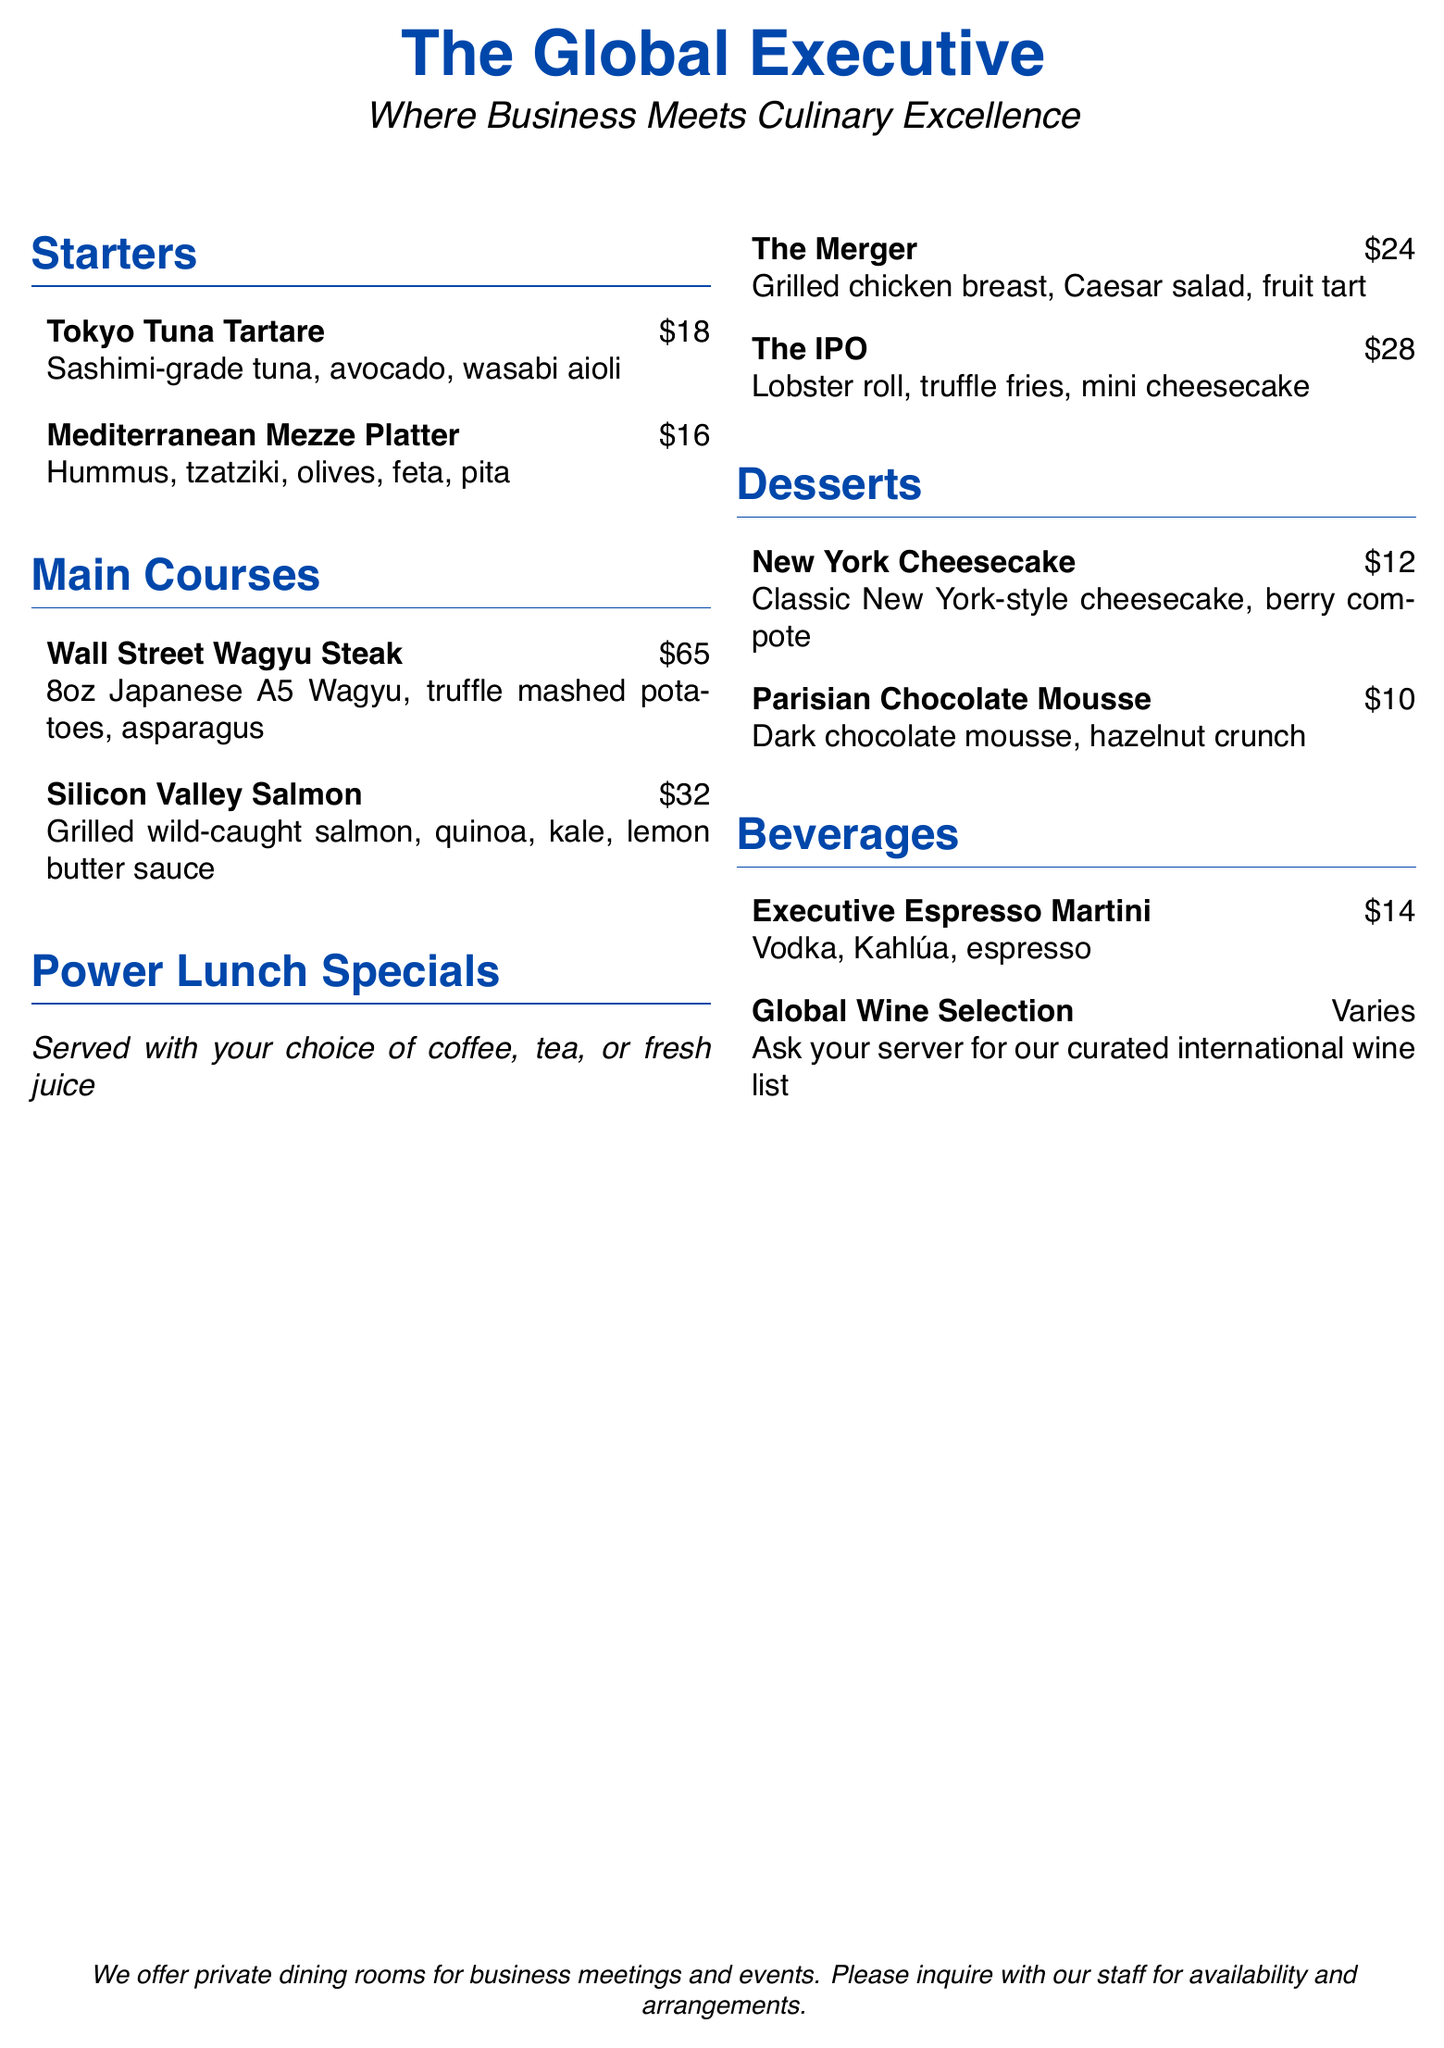what is the price of the Tokyo Tuna Tartare? The price is listed next to the dish in the menu.
Answer: $18 what are the components of the Mediterranean Mezze Platter? The dish details what is included in the platter in the menu.
Answer: Hummus, tzatziki, olives, feta, pita how much does the Wall Street Wagyu Steak cost? The price is provided alongside the dish in the main courses section.
Answer: $65 what is included in the Power Lunch Special called "The IPO"? The special details its components in the menu.
Answer: Lobster roll, truffle fries, mini cheesecake which dessert features chocolate mousse? The dessert section names the dessert in question.
Answer: Parisian Chocolate Mousse what beverage features vodka and espresso? The ingredients are listed under the beverages section of the menu.
Answer: Executive Espresso Martini how many items are listed under the Starters section? The number of items can be counted in that section of the menu.
Answer: 2 what is the tagline of the restaurant? The tagline is presented prominently at the top of the document.
Answer: Where Business Meets Culinary Excellence what type of dining arrangements does the restaurant offer for business meetings? The menu states the types of arrangements available.
Answer: Private dining rooms 